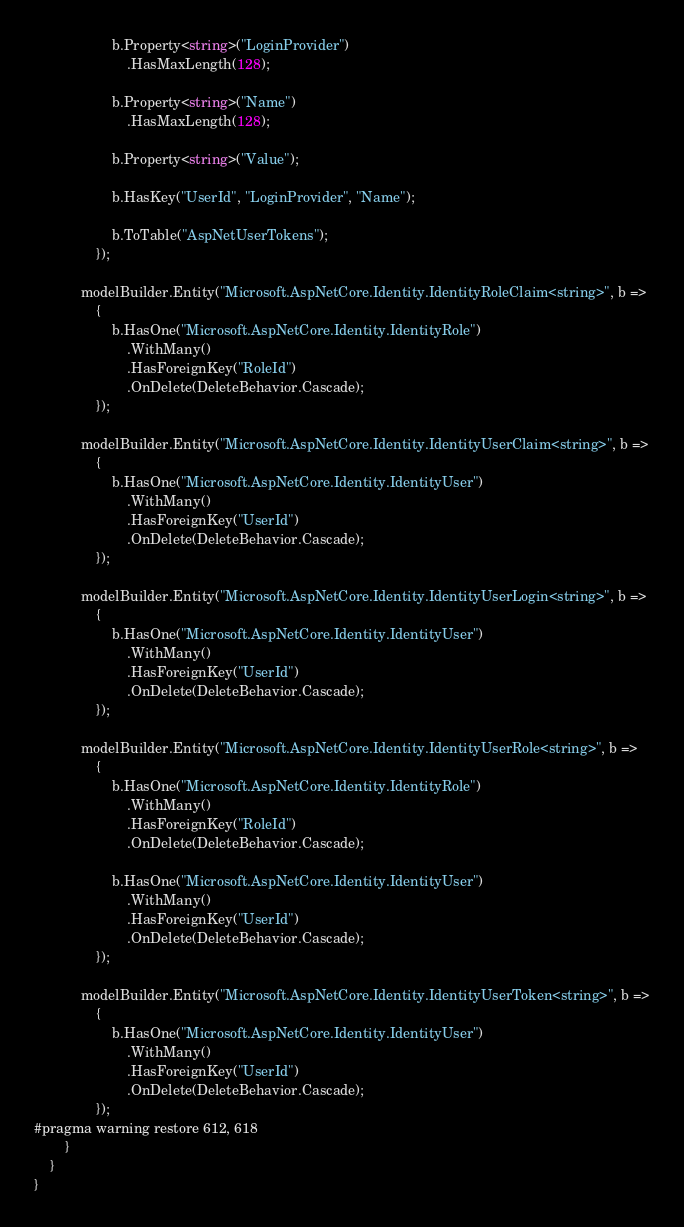Convert code to text. <code><loc_0><loc_0><loc_500><loc_500><_C#_>                    b.Property<string>("LoginProvider")
                        .HasMaxLength(128);

                    b.Property<string>("Name")
                        .HasMaxLength(128);

                    b.Property<string>("Value");

                    b.HasKey("UserId", "LoginProvider", "Name");

                    b.ToTable("AspNetUserTokens");
                });

            modelBuilder.Entity("Microsoft.AspNetCore.Identity.IdentityRoleClaim<string>", b =>
                {
                    b.HasOne("Microsoft.AspNetCore.Identity.IdentityRole")
                        .WithMany()
                        .HasForeignKey("RoleId")
                        .OnDelete(DeleteBehavior.Cascade);
                });

            modelBuilder.Entity("Microsoft.AspNetCore.Identity.IdentityUserClaim<string>", b =>
                {
                    b.HasOne("Microsoft.AspNetCore.Identity.IdentityUser")
                        .WithMany()
                        .HasForeignKey("UserId")
                        .OnDelete(DeleteBehavior.Cascade);
                });

            modelBuilder.Entity("Microsoft.AspNetCore.Identity.IdentityUserLogin<string>", b =>
                {
                    b.HasOne("Microsoft.AspNetCore.Identity.IdentityUser")
                        .WithMany()
                        .HasForeignKey("UserId")
                        .OnDelete(DeleteBehavior.Cascade);
                });

            modelBuilder.Entity("Microsoft.AspNetCore.Identity.IdentityUserRole<string>", b =>
                {
                    b.HasOne("Microsoft.AspNetCore.Identity.IdentityRole")
                        .WithMany()
                        .HasForeignKey("RoleId")
                        .OnDelete(DeleteBehavior.Cascade);

                    b.HasOne("Microsoft.AspNetCore.Identity.IdentityUser")
                        .WithMany()
                        .HasForeignKey("UserId")
                        .OnDelete(DeleteBehavior.Cascade);
                });

            modelBuilder.Entity("Microsoft.AspNetCore.Identity.IdentityUserToken<string>", b =>
                {
                    b.HasOne("Microsoft.AspNetCore.Identity.IdentityUser")
                        .WithMany()
                        .HasForeignKey("UserId")
                        .OnDelete(DeleteBehavior.Cascade);
                });
#pragma warning restore 612, 618
        }
    }
}
</code> 